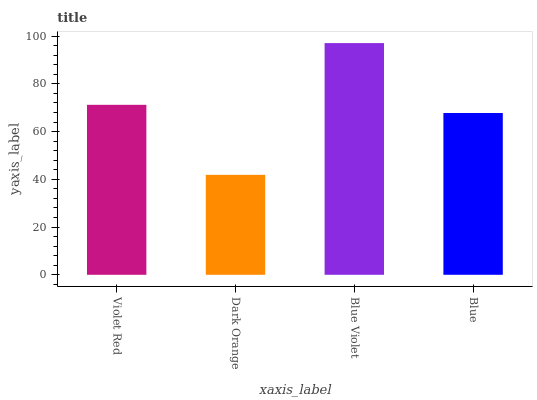Is Blue Violet the minimum?
Answer yes or no. No. Is Dark Orange the maximum?
Answer yes or no. No. Is Blue Violet greater than Dark Orange?
Answer yes or no. Yes. Is Dark Orange less than Blue Violet?
Answer yes or no. Yes. Is Dark Orange greater than Blue Violet?
Answer yes or no. No. Is Blue Violet less than Dark Orange?
Answer yes or no. No. Is Violet Red the high median?
Answer yes or no. Yes. Is Blue the low median?
Answer yes or no. Yes. Is Dark Orange the high median?
Answer yes or no. No. Is Blue Violet the low median?
Answer yes or no. No. 